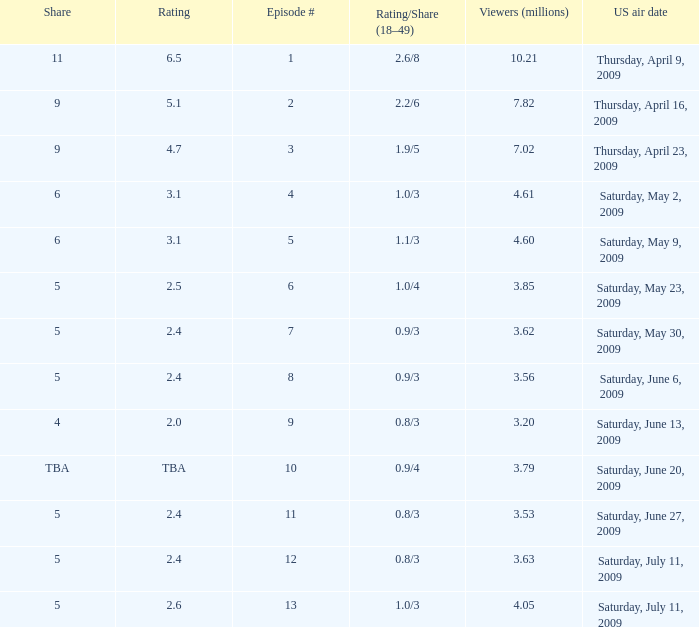What is the lowest number of million viewers for an episode before episode 5 with a rating/share of 1.1/3? None. 